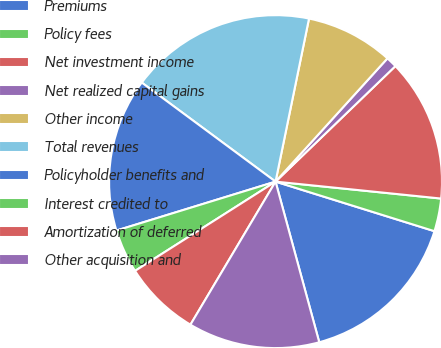<chart> <loc_0><loc_0><loc_500><loc_500><pie_chart><fcel>Premiums<fcel>Policy fees<fcel>Net investment income<fcel>Net realized capital gains<fcel>Other income<fcel>Total revenues<fcel>Policyholder benefits and<fcel>Interest credited to<fcel>Amortization of deferred<fcel>Other acquisition and<nl><fcel>15.96%<fcel>3.19%<fcel>13.83%<fcel>1.06%<fcel>8.51%<fcel>18.08%<fcel>14.89%<fcel>4.26%<fcel>7.45%<fcel>12.77%<nl></chart> 